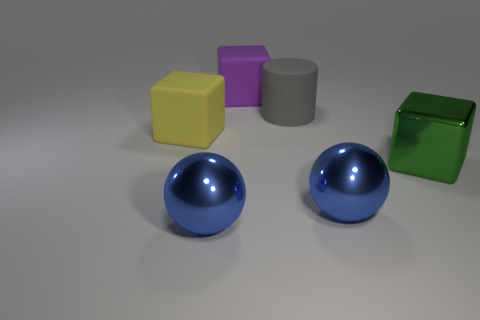There is a yellow object that is the same material as the gray cylinder; what is its shape?
Ensure brevity in your answer.  Cube. What material is the large thing in front of the large blue metal sphere that is right of the metal sphere on the left side of the big purple matte cube?
Provide a short and direct response. Metal. There is a green block; does it have the same size as the shiny thing left of the large purple rubber block?
Make the answer very short. Yes. There is a yellow thing that is the same shape as the green thing; what material is it?
Keep it short and to the point. Rubber. There is a block that is behind the rubber block left of the matte cube behind the big yellow rubber object; what size is it?
Your answer should be compact. Large. Is the size of the purple block the same as the gray cylinder?
Provide a succinct answer. Yes. What is the material of the blue object that is on the right side of the rubber block that is behind the large yellow block?
Ensure brevity in your answer.  Metal. Does the rubber object to the right of the purple rubber object have the same shape as the blue object to the left of the large cylinder?
Your response must be concise. No. Is the number of blue balls on the left side of the large cylinder the same as the number of shiny cubes?
Your response must be concise. Yes. Are there any cubes on the left side of the matte block that is to the right of the yellow cube?
Keep it short and to the point. Yes. 